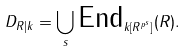Convert formula to latex. <formula><loc_0><loc_0><loc_500><loc_500>D _ { R | k } = \bigcup _ { s } \text {End} _ { k [ R ^ { p ^ { s } } ] } ( R ) .</formula> 